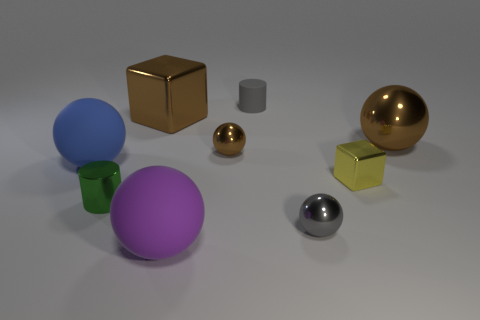Subtract 2 spheres. How many spheres are left? 3 Subtract all gray spheres. How many spheres are left? 4 Subtract all big brown balls. How many balls are left? 4 Subtract all green balls. Subtract all cyan cubes. How many balls are left? 5 Subtract all cubes. How many objects are left? 7 Add 5 blue metal cylinders. How many blue metal cylinders exist? 5 Subtract 0 red blocks. How many objects are left? 9 Subtract all matte cylinders. Subtract all purple things. How many objects are left? 7 Add 1 tiny metallic cubes. How many tiny metallic cubes are left? 2 